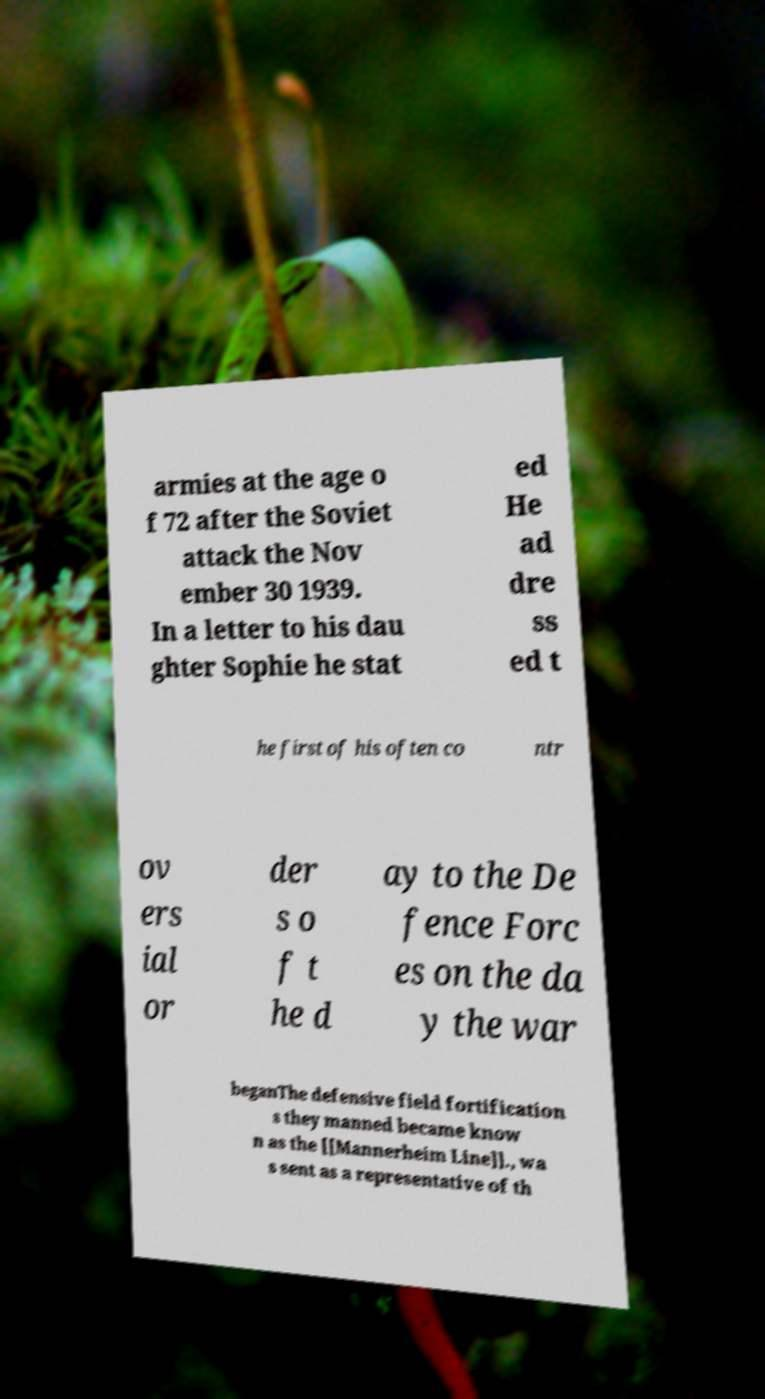There's text embedded in this image that I need extracted. Can you transcribe it verbatim? armies at the age o f 72 after the Soviet attack the Nov ember 30 1939. In a letter to his dau ghter Sophie he stat ed He ad dre ss ed t he first of his often co ntr ov ers ial or der s o f t he d ay to the De fence Forc es on the da y the war beganThe defensive field fortification s they manned became know n as the [[Mannerheim Line]]., wa s sent as a representative of th 